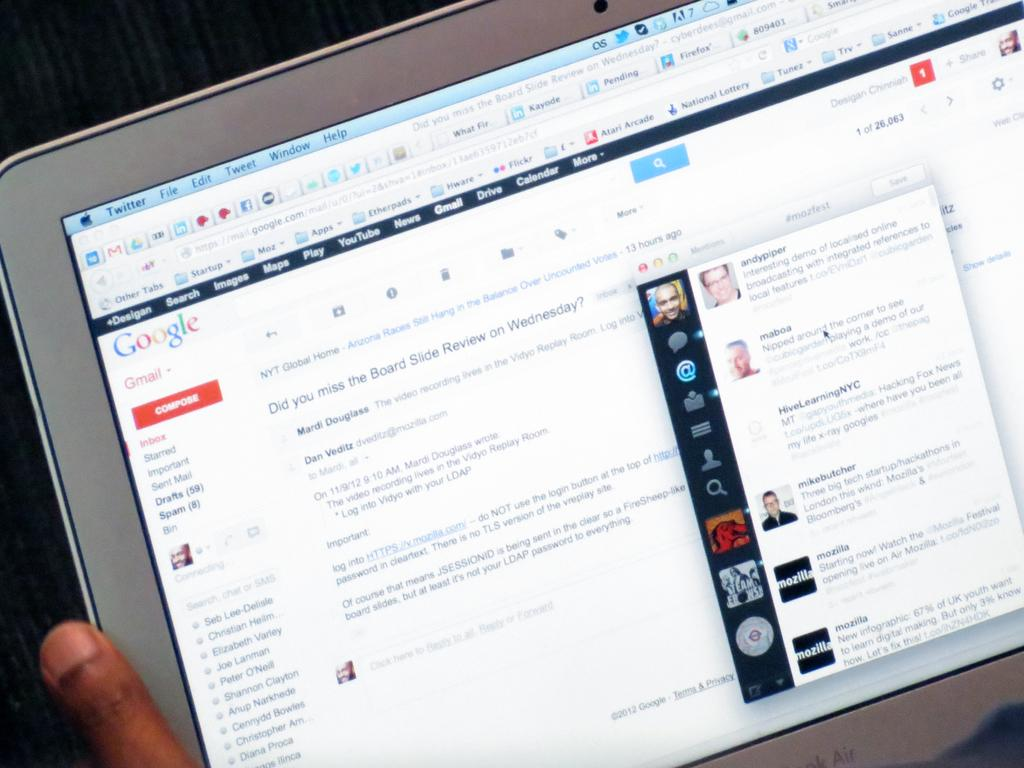What is the main subject of the image? There is a person in the image. What is the person holding in the image? The person is holding a laptop. What can be seen on the screen of the laptop? There is text visible on the screen of the laptop. Can you tell me how many horses are present in the image? There are no horses present in the image; it features a person holding a laptop. What type of brass object can be seen on the person's desk in the image? There is no brass object visible in the image. 